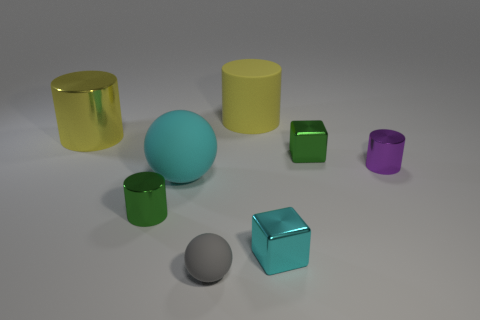If these objects were in a game, what kind of game do you think it would be and why? Given the simplicity and abstract nature of the objects, they could be from a puzzle or educational game designed to teach principles of geometry and physics. The various shapes and colors might be used to challenge players to solve spatial reasoning puzzles or to learn about light and material properties in a virtual environment. 